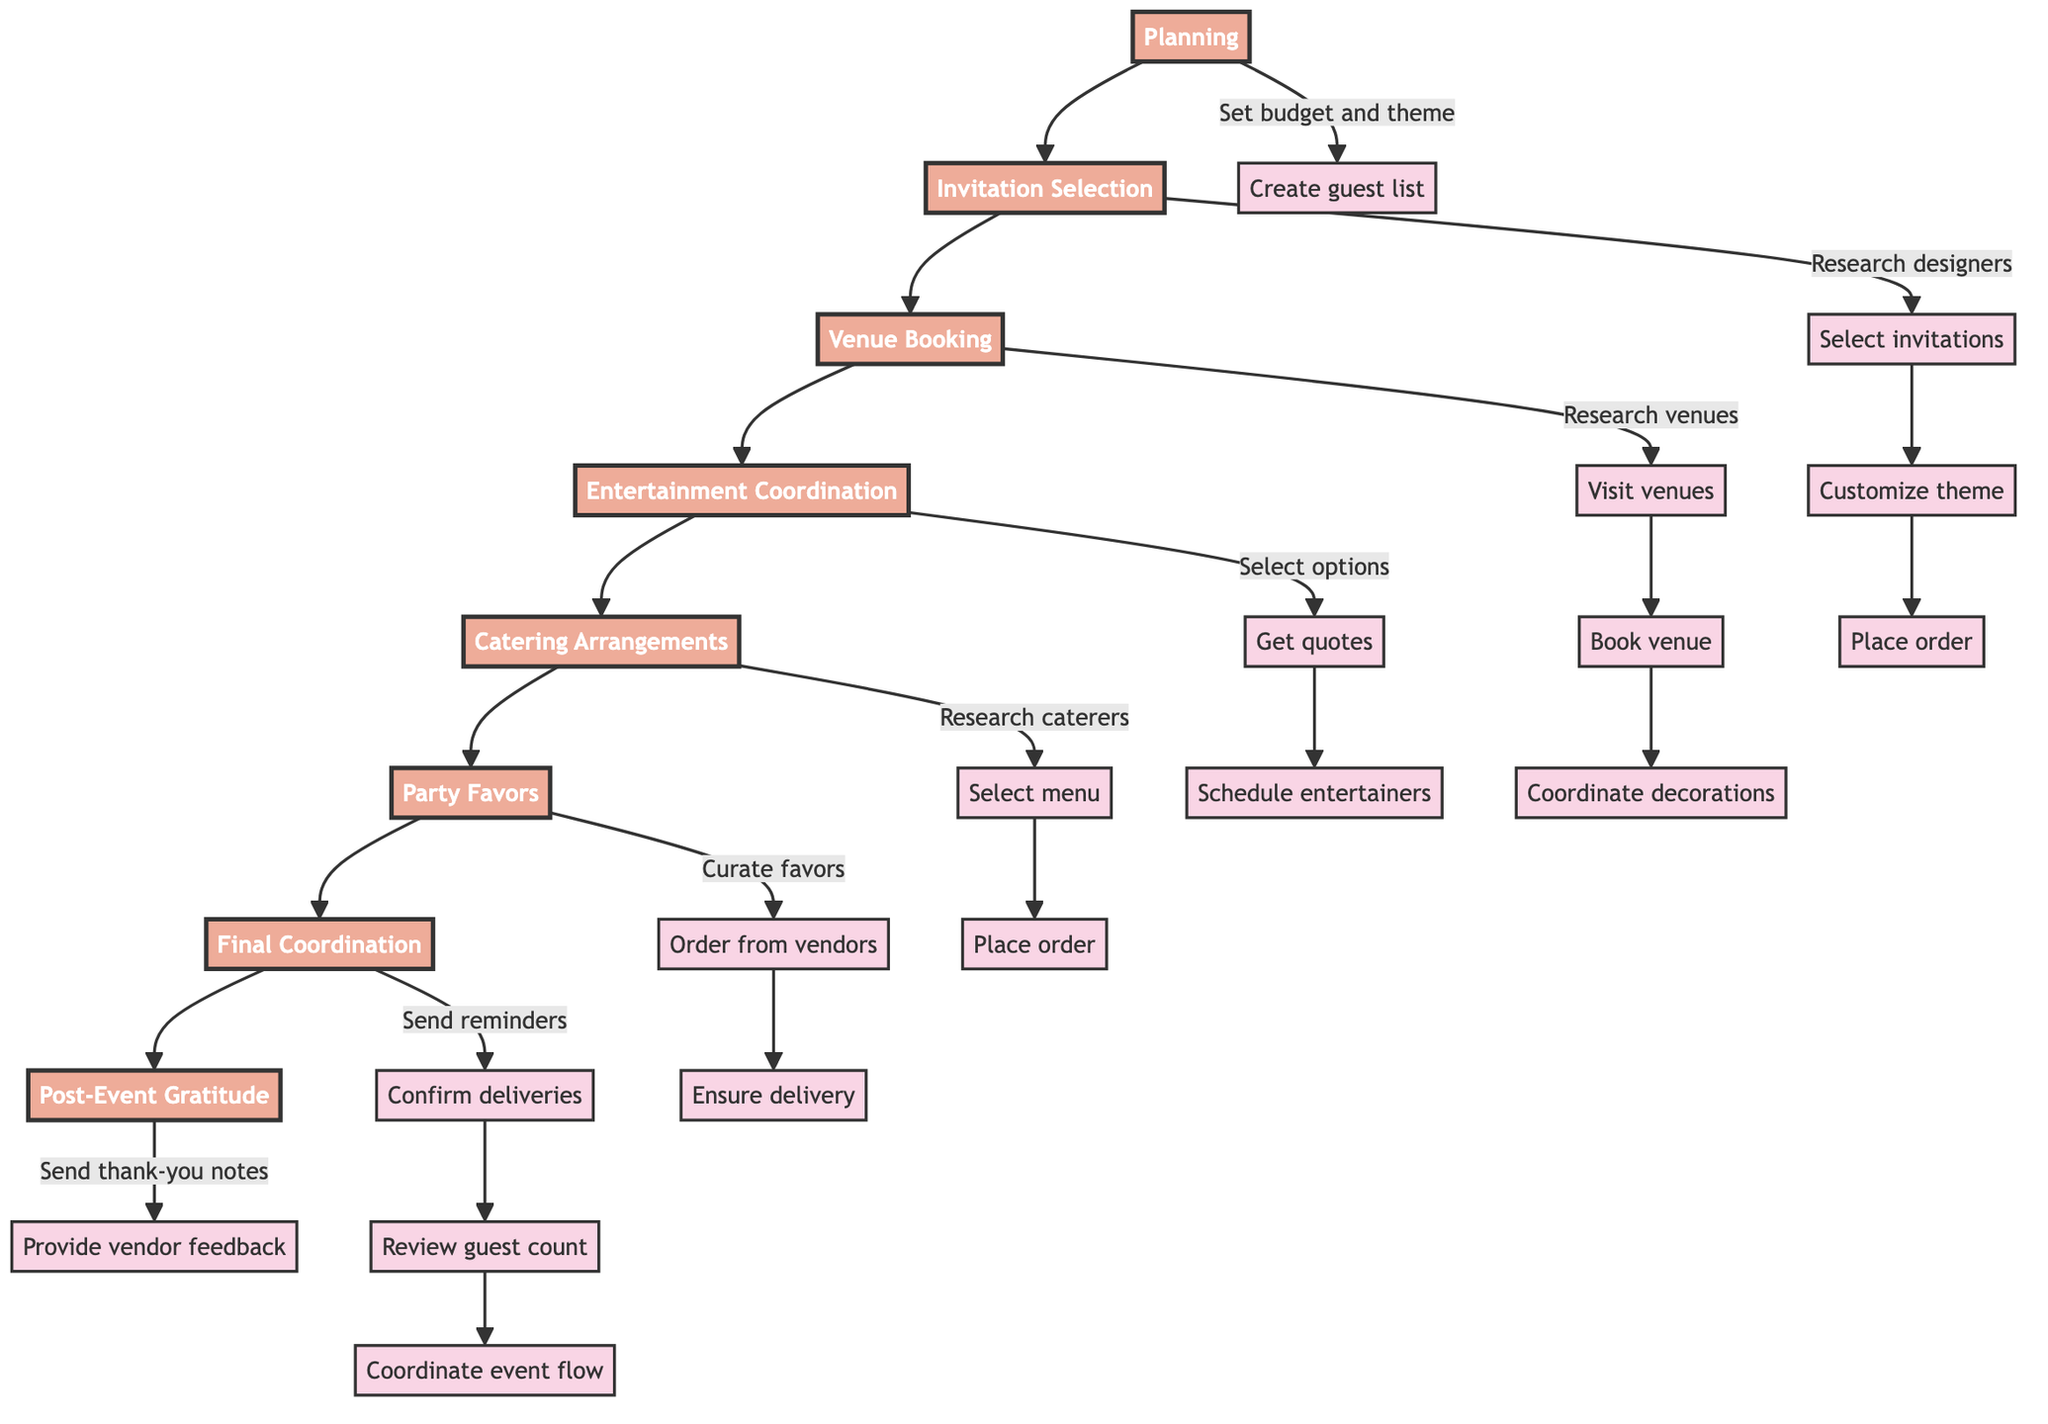What is the first stage in the flow chart? The first stage in the flow chart is shown at the top and is labeled "Planning."
Answer: Planning How many stages are there in total? Counting the stages from "Planning" to "Post-Event Gratitude," there are a total of 8 stages in the flow chart.
Answer: 8 Which vendor type is associated with the "Catering Arrangements" stage? In the "Catering Arrangements" stage, the diagram indicates that gourmet caterers are the vendor type being researched.
Answer: Gourmet caterers What is the last task in the "Final Coordination" stage? The last task shown in the "Final Coordination" stage is "Coordinate event flow with vendors on the day."
Answer: Coordinate event flow with vendors on the day What task follows "Customize with kid's favorite themes"? The task that follows "Customize with kid's favorite themes" is "Place an order with vendor."
Answer: Place an order with vendor How does the "Venue Booking" stage relate to "Entertainment Coordination"? After the "Venue Booking" stage is completed, the next stage is "Entertainment Coordination," indicating a sequential relationship where entertainment is planned after the venue is booked.
Answer: Sequential relationship Which stage includes sending thank-you notes? The stage that includes sending thank-you notes is labeled "Post-Event Gratitude."
Answer: Post-Event Gratitude What task is directly connected to "Research top venues"? The task that is directly connected to "Research top venues" is "Visit venues for suitability checks."
Answer: Visit venues for suitability checks Which stage comes right before "Party Favors"? The stage that comes right before "Party Favors" is "Catering Arrangements."
Answer: Catering Arrangements 